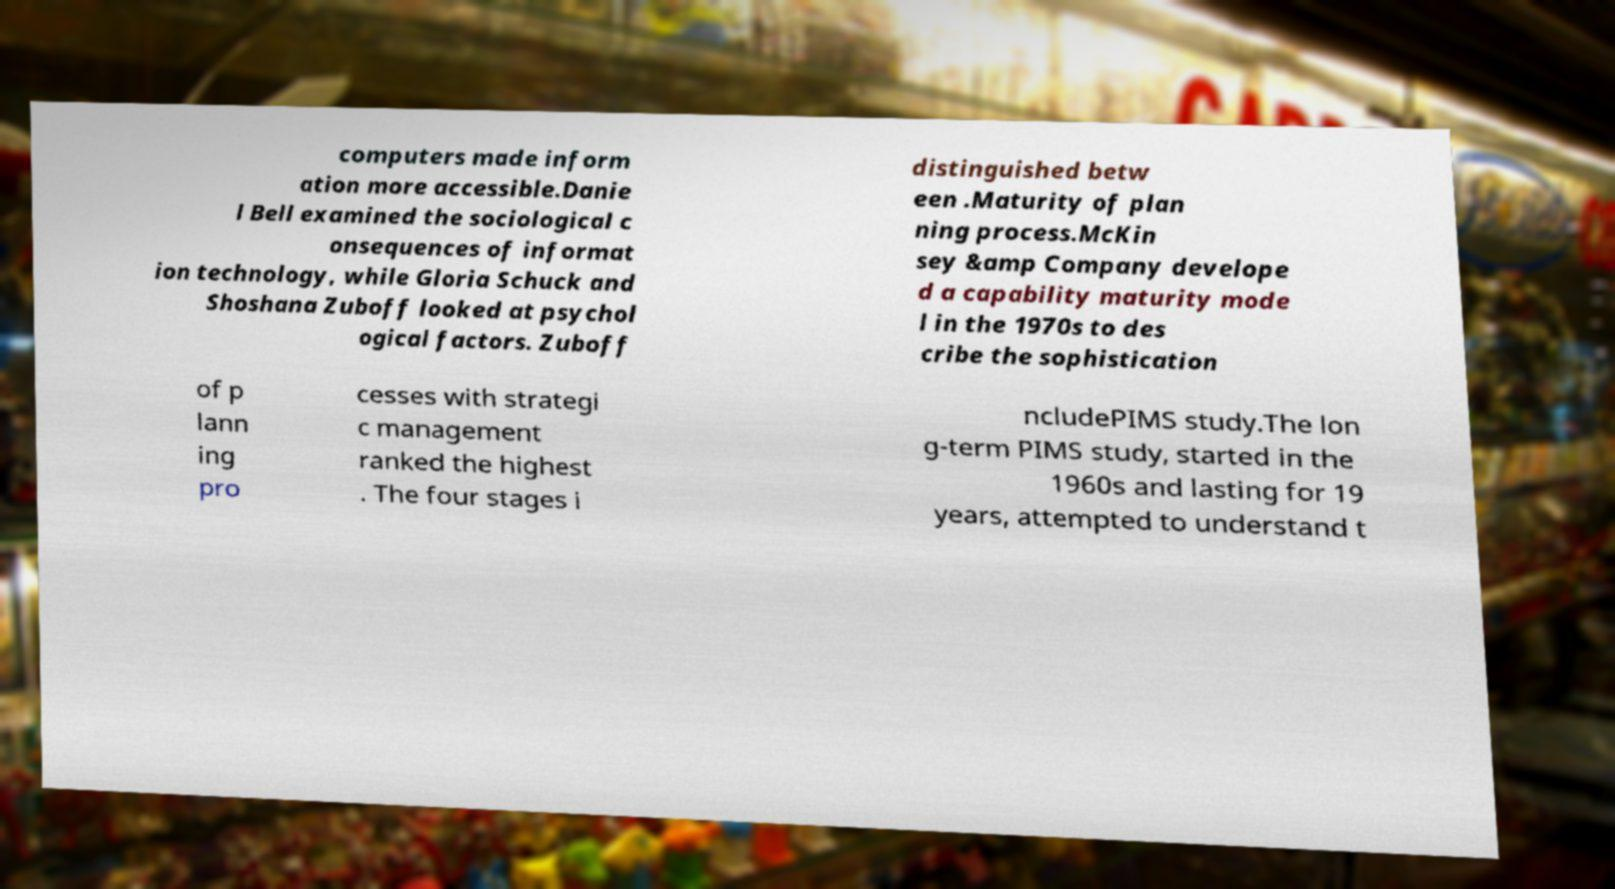What messages or text are displayed in this image? I need them in a readable, typed format. computers made inform ation more accessible.Danie l Bell examined the sociological c onsequences of informat ion technology, while Gloria Schuck and Shoshana Zuboff looked at psychol ogical factors. Zuboff distinguished betw een .Maturity of plan ning process.McKin sey &amp Company develope d a capability maturity mode l in the 1970s to des cribe the sophistication of p lann ing pro cesses with strategi c management ranked the highest . The four stages i ncludePIMS study.The lon g-term PIMS study, started in the 1960s and lasting for 19 years, attempted to understand t 